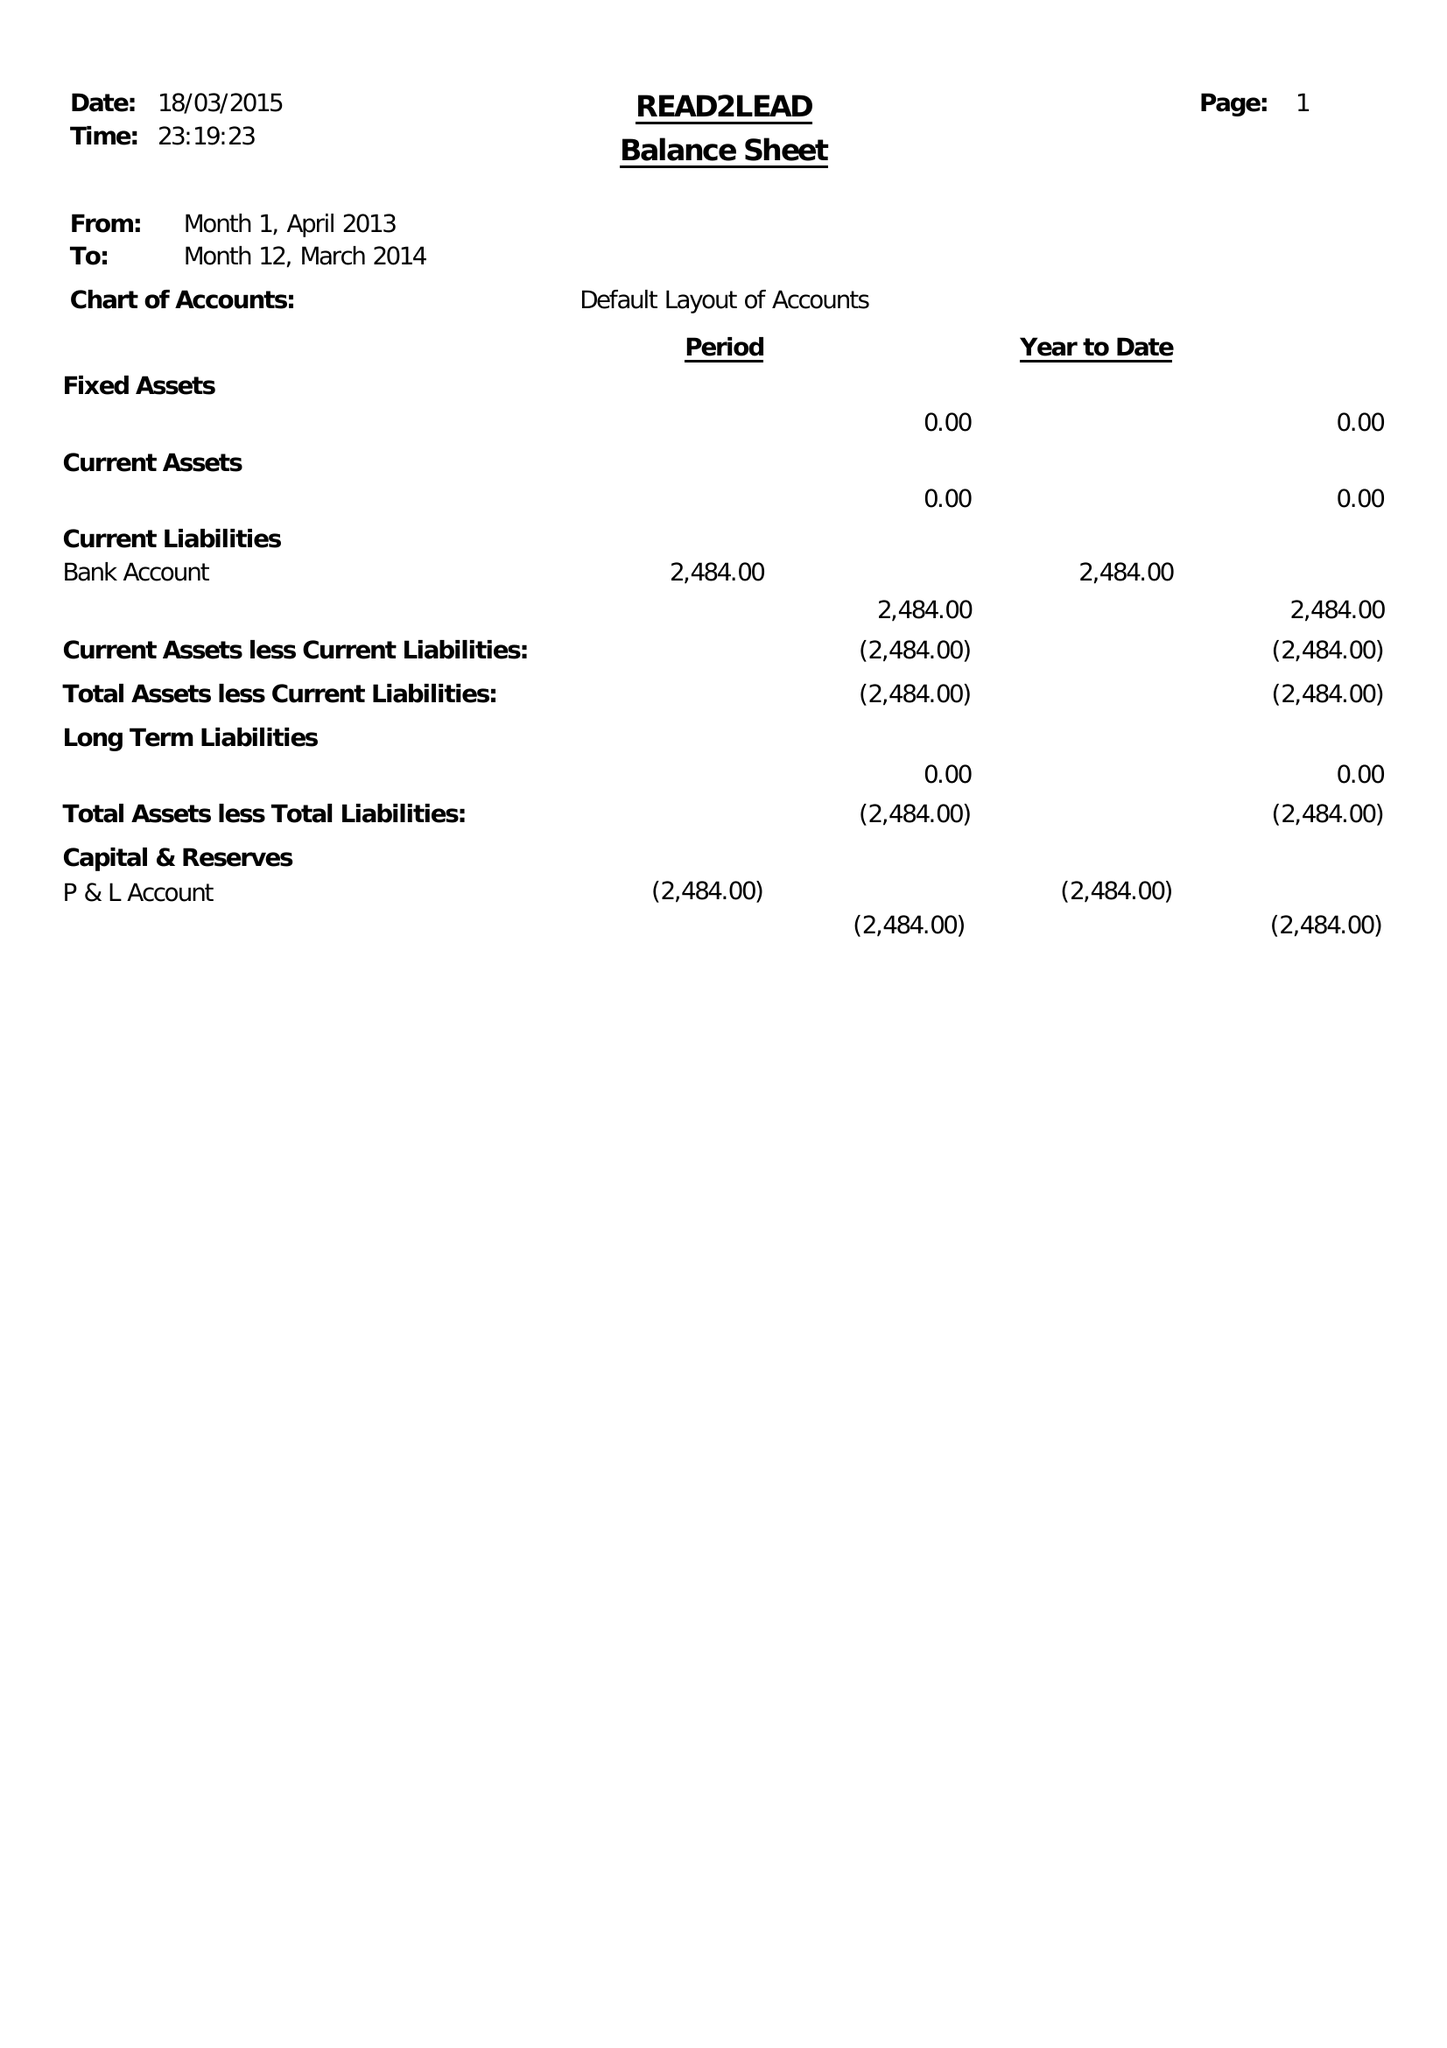What is the value for the address__postcode?
Answer the question using a single word or phrase. B8 1RS 